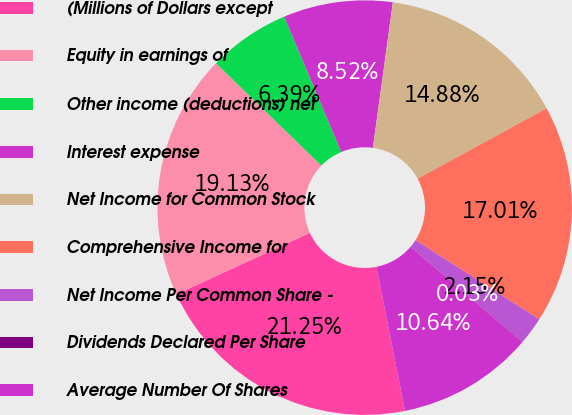<chart> <loc_0><loc_0><loc_500><loc_500><pie_chart><fcel>(Millions of Dollars except<fcel>Equity in earnings of<fcel>Other income (deductions) net<fcel>Interest expense<fcel>Net Income for Common Stock<fcel>Comprehensive Income for<fcel>Net Income Per Common Share -<fcel>Dividends Declared Per Share<fcel>Average Number Of Shares<nl><fcel>21.25%<fcel>19.13%<fcel>6.39%<fcel>8.52%<fcel>14.88%<fcel>17.01%<fcel>2.15%<fcel>0.03%<fcel>10.64%<nl></chart> 